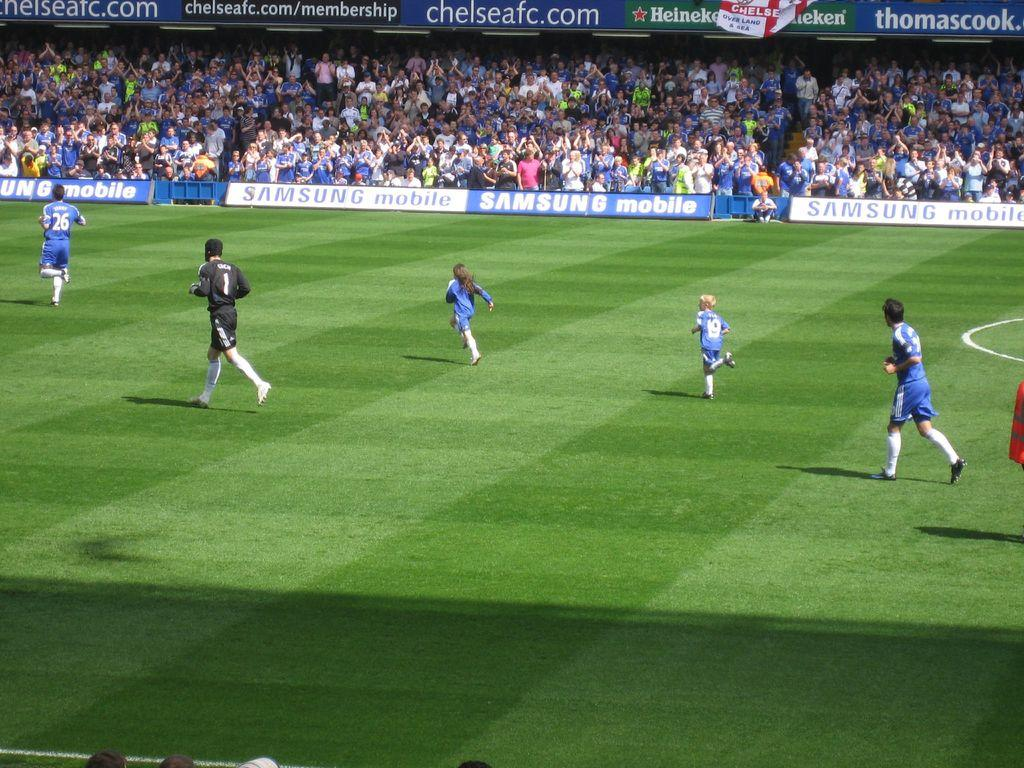<image>
Write a terse but informative summary of the picture. A group of soccer players playing in a stadium that has advertising Chelseafc.com. 